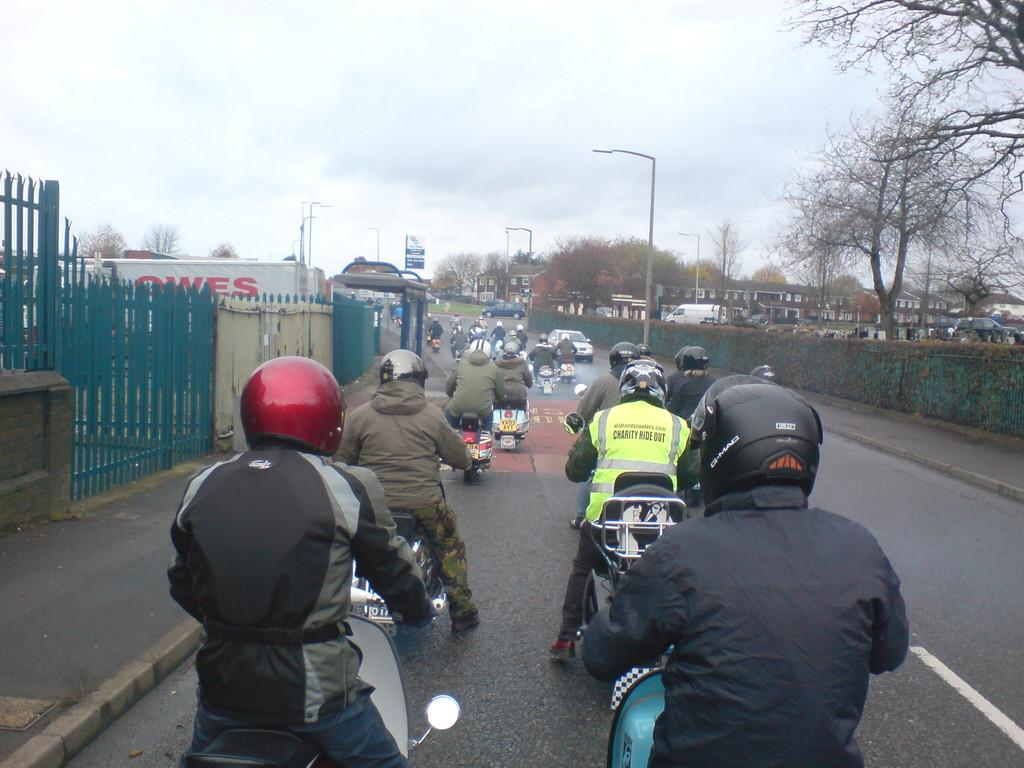What are the people in the image doing? The people in the image are on their bikes. What else can be seen in the image besides the people on bikes? There are other vehicles and trees visible in the image. What type of lighting is present in the image? Street lights are visible in the image. What safety precaution are the people on bikes taking? The people on bikes are wearing helmets. What type of pickle is being used as a prop in the image? There is no pickle present in the image. What type of fowl can be seen flying in the image? There is no fowl visible in the image. 